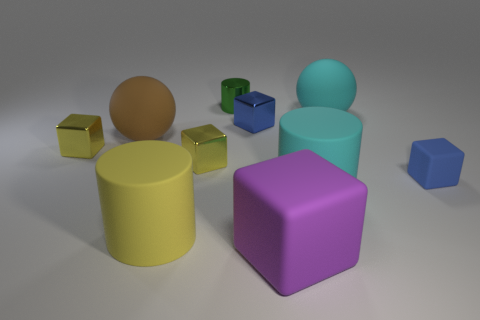How many other things are there of the same color as the big matte cube?
Offer a very short reply. 0. There is a brown object that is the same size as the cyan ball; what shape is it?
Offer a terse response. Sphere. There is a big cyan matte thing that is behind the small yellow object that is to the left of the big brown rubber ball; what number of big yellow matte things are on the right side of it?
Give a very brief answer. 0. How many rubber objects are either big cyan spheres or yellow cylinders?
Your answer should be very brief. 2. The block that is on the right side of the tiny blue metal object and behind the big purple rubber thing is what color?
Provide a short and direct response. Blue. Does the blue object that is behind the brown thing have the same size as the yellow matte cylinder?
Provide a succinct answer. No. How many objects are small yellow blocks that are to the left of the yellow cylinder or blocks?
Ensure brevity in your answer.  5. Are there any green metallic cylinders that have the same size as the cyan rubber cylinder?
Keep it short and to the point. No. There is a purple object that is the same size as the brown rubber ball; what is its material?
Give a very brief answer. Rubber. What is the shape of the matte thing that is both in front of the cyan rubber cylinder and on the left side of the large rubber block?
Ensure brevity in your answer.  Cylinder. 